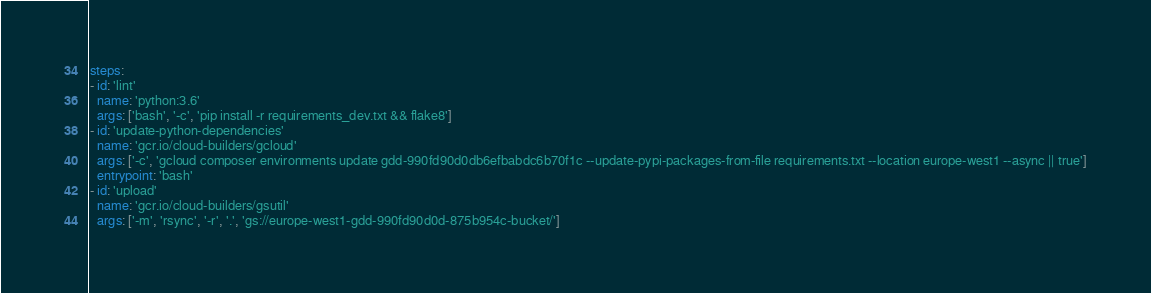Convert code to text. <code><loc_0><loc_0><loc_500><loc_500><_YAML_>steps:
- id: 'lint'
  name: 'python:3.6'
  args: ['bash', '-c', 'pip install -r requirements_dev.txt && flake8']
- id: 'update-python-dependencies'
  name: 'gcr.io/cloud-builders/gcloud'
  args: ['-c', 'gcloud composer environments update gdd-990fd90d0db6efbabdc6b70f1c --update-pypi-packages-from-file requirements.txt --location europe-west1 --async || true']
  entrypoint: 'bash'
- id: 'upload'
  name: 'gcr.io/cloud-builders/gsutil'
  args: ['-m', 'rsync', '-r', '.', 'gs://europe-west1-gdd-990fd90d0d-875b954c-bucket/']
</code> 